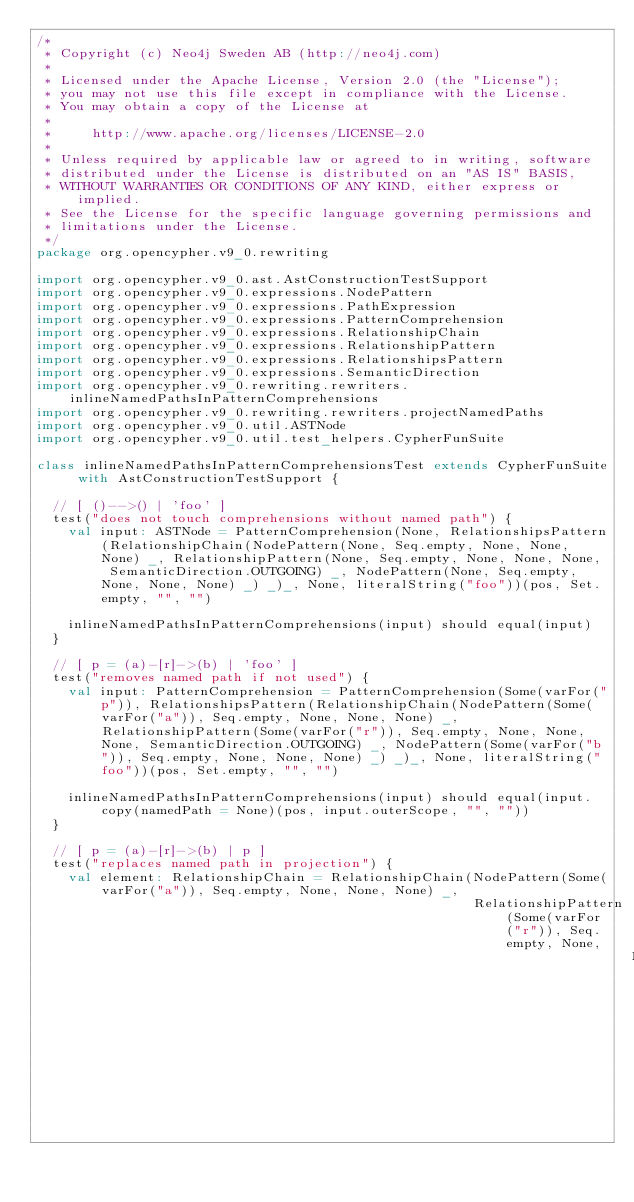<code> <loc_0><loc_0><loc_500><loc_500><_Scala_>/*
 * Copyright (c) Neo4j Sweden AB (http://neo4j.com)
 *
 * Licensed under the Apache License, Version 2.0 (the "License");
 * you may not use this file except in compliance with the License.
 * You may obtain a copy of the License at
 *
 *     http://www.apache.org/licenses/LICENSE-2.0
 *
 * Unless required by applicable law or agreed to in writing, software
 * distributed under the License is distributed on an "AS IS" BASIS,
 * WITHOUT WARRANTIES OR CONDITIONS OF ANY KIND, either express or implied.
 * See the License for the specific language governing permissions and
 * limitations under the License.
 */
package org.opencypher.v9_0.rewriting

import org.opencypher.v9_0.ast.AstConstructionTestSupport
import org.opencypher.v9_0.expressions.NodePattern
import org.opencypher.v9_0.expressions.PathExpression
import org.opencypher.v9_0.expressions.PatternComprehension
import org.opencypher.v9_0.expressions.RelationshipChain
import org.opencypher.v9_0.expressions.RelationshipPattern
import org.opencypher.v9_0.expressions.RelationshipsPattern
import org.opencypher.v9_0.expressions.SemanticDirection
import org.opencypher.v9_0.rewriting.rewriters.inlineNamedPathsInPatternComprehensions
import org.opencypher.v9_0.rewriting.rewriters.projectNamedPaths
import org.opencypher.v9_0.util.ASTNode
import org.opencypher.v9_0.util.test_helpers.CypherFunSuite

class inlineNamedPathsInPatternComprehensionsTest extends CypherFunSuite with AstConstructionTestSupport {

  // [ ()-->() | 'foo' ]
  test("does not touch comprehensions without named path") {
    val input: ASTNode = PatternComprehension(None, RelationshipsPattern(RelationshipChain(NodePattern(None, Seq.empty, None, None, None) _, RelationshipPattern(None, Seq.empty, None, None, None, SemanticDirection.OUTGOING) _, NodePattern(None, Seq.empty, None, None, None) _) _)_, None, literalString("foo"))(pos, Set.empty, "", "")

    inlineNamedPathsInPatternComprehensions(input) should equal(input)
  }

  // [ p = (a)-[r]->(b) | 'foo' ]
  test("removes named path if not used") {
    val input: PatternComprehension = PatternComprehension(Some(varFor("p")), RelationshipsPattern(RelationshipChain(NodePattern(Some(varFor("a")), Seq.empty, None, None, None) _, RelationshipPattern(Some(varFor("r")), Seq.empty, None, None, None, SemanticDirection.OUTGOING) _, NodePattern(Some(varFor("b")), Seq.empty, None, None, None) _) _)_, None, literalString("foo"))(pos, Set.empty, "", "")

    inlineNamedPathsInPatternComprehensions(input) should equal(input.copy(namedPath = None)(pos, input.outerScope, "", ""))
  }

  // [ p = (a)-[r]->(b) | p ]
  test("replaces named path in projection") {
    val element: RelationshipChain = RelationshipChain(NodePattern(Some(varFor("a")), Seq.empty, None, None, None) _,
                                                       RelationshipPattern(Some(varFor("r")), Seq.empty, None,
                                                                           None, None, SemanticDirection.OUTGOING) _,</code> 